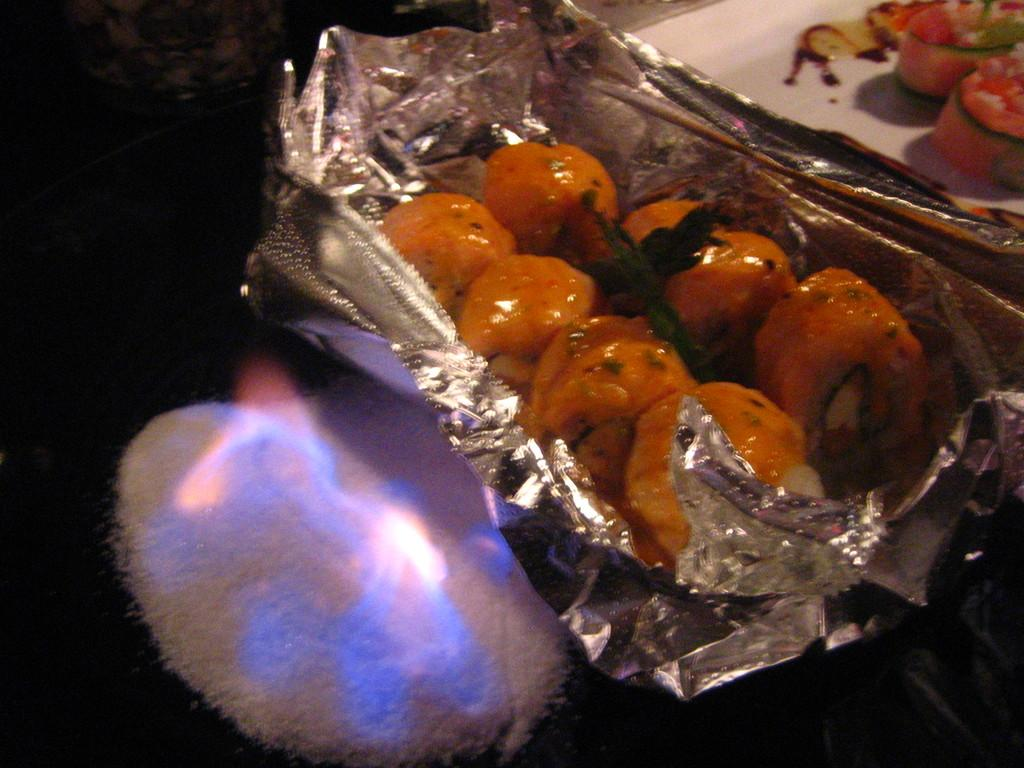What is present in the image that people typically eat? There is food in the image. What is the food placed on in the image? There is a plate in the image. What else can be seen in the image besides the food and plate? There is a container in the image. What is the source of heat or light in the image? There is fire visible in the image. What type of vacation is being advertised in the image? There is no vacation being advertised in the image; it features food, a plate, a container, and fire. What color are the eyes of the person in the image? There are no people or eyes present in the image. 